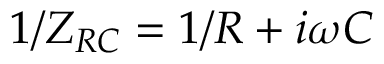<formula> <loc_0><loc_0><loc_500><loc_500>1 / Z _ { R C } = 1 / R + i \omega C</formula> 